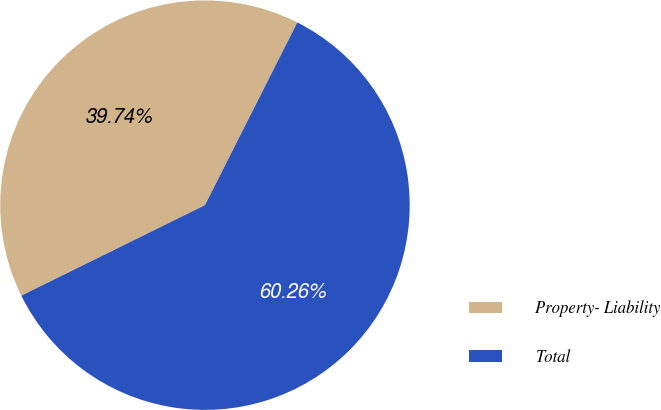Convert chart to OTSL. <chart><loc_0><loc_0><loc_500><loc_500><pie_chart><fcel>Property- Liability<fcel>Total<nl><fcel>39.74%<fcel>60.26%<nl></chart> 